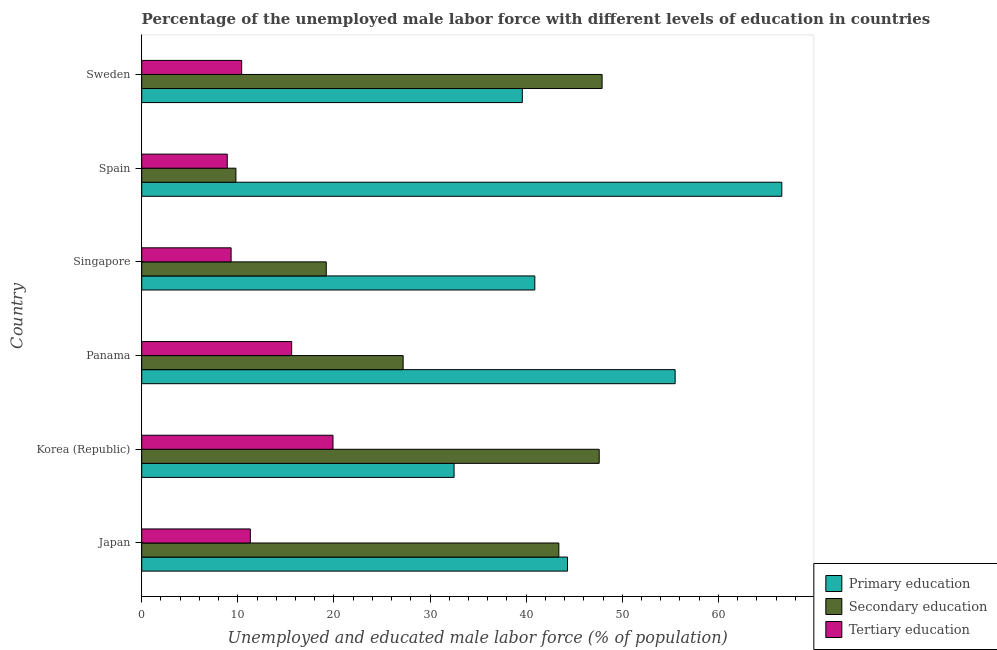How many different coloured bars are there?
Ensure brevity in your answer.  3. How many groups of bars are there?
Give a very brief answer. 6. How many bars are there on the 6th tick from the bottom?
Make the answer very short. 3. In how many cases, is the number of bars for a given country not equal to the number of legend labels?
Provide a succinct answer. 0. What is the percentage of male labor force who received tertiary education in Korea (Republic)?
Give a very brief answer. 19.9. Across all countries, what is the maximum percentage of male labor force who received tertiary education?
Offer a terse response. 19.9. Across all countries, what is the minimum percentage of male labor force who received primary education?
Your answer should be very brief. 32.5. In which country was the percentage of male labor force who received primary education maximum?
Your answer should be very brief. Spain. What is the total percentage of male labor force who received secondary education in the graph?
Keep it short and to the point. 195.1. What is the difference between the percentage of male labor force who received tertiary education in Korea (Republic) and that in Singapore?
Ensure brevity in your answer.  10.6. What is the difference between the percentage of male labor force who received tertiary education in Japan and the percentage of male labor force who received primary education in Singapore?
Offer a very short reply. -29.6. What is the average percentage of male labor force who received tertiary education per country?
Ensure brevity in your answer.  12.57. What is the difference between the percentage of male labor force who received primary education and percentage of male labor force who received tertiary education in Sweden?
Keep it short and to the point. 29.2. In how many countries, is the percentage of male labor force who received tertiary education greater than 16 %?
Your answer should be very brief. 1. What is the ratio of the percentage of male labor force who received tertiary education in Japan to that in Spain?
Offer a terse response. 1.27. Is the percentage of male labor force who received primary education in Panama less than that in Sweden?
Keep it short and to the point. No. What is the difference between the highest and the second highest percentage of male labor force who received primary education?
Make the answer very short. 11.1. What is the difference between the highest and the lowest percentage of male labor force who received secondary education?
Your answer should be very brief. 38.1. In how many countries, is the percentage of male labor force who received primary education greater than the average percentage of male labor force who received primary education taken over all countries?
Offer a very short reply. 2. Is the sum of the percentage of male labor force who received primary education in Singapore and Spain greater than the maximum percentage of male labor force who received tertiary education across all countries?
Give a very brief answer. Yes. What does the 1st bar from the top in Sweden represents?
Make the answer very short. Tertiary education. What does the 3rd bar from the bottom in Spain represents?
Your answer should be compact. Tertiary education. What is the difference between two consecutive major ticks on the X-axis?
Keep it short and to the point. 10. How many legend labels are there?
Your answer should be compact. 3. How are the legend labels stacked?
Your response must be concise. Vertical. What is the title of the graph?
Offer a very short reply. Percentage of the unemployed male labor force with different levels of education in countries. Does "Ages 20-60" appear as one of the legend labels in the graph?
Provide a short and direct response. No. What is the label or title of the X-axis?
Provide a short and direct response. Unemployed and educated male labor force (% of population). What is the label or title of the Y-axis?
Offer a very short reply. Country. What is the Unemployed and educated male labor force (% of population) in Primary education in Japan?
Your response must be concise. 44.3. What is the Unemployed and educated male labor force (% of population) in Secondary education in Japan?
Your answer should be very brief. 43.4. What is the Unemployed and educated male labor force (% of population) in Tertiary education in Japan?
Provide a succinct answer. 11.3. What is the Unemployed and educated male labor force (% of population) in Primary education in Korea (Republic)?
Offer a very short reply. 32.5. What is the Unemployed and educated male labor force (% of population) of Secondary education in Korea (Republic)?
Provide a succinct answer. 47.6. What is the Unemployed and educated male labor force (% of population) in Tertiary education in Korea (Republic)?
Make the answer very short. 19.9. What is the Unemployed and educated male labor force (% of population) of Primary education in Panama?
Keep it short and to the point. 55.5. What is the Unemployed and educated male labor force (% of population) in Secondary education in Panama?
Give a very brief answer. 27.2. What is the Unemployed and educated male labor force (% of population) in Tertiary education in Panama?
Your answer should be compact. 15.6. What is the Unemployed and educated male labor force (% of population) in Primary education in Singapore?
Provide a short and direct response. 40.9. What is the Unemployed and educated male labor force (% of population) in Secondary education in Singapore?
Your response must be concise. 19.2. What is the Unemployed and educated male labor force (% of population) of Tertiary education in Singapore?
Your response must be concise. 9.3. What is the Unemployed and educated male labor force (% of population) in Primary education in Spain?
Keep it short and to the point. 66.6. What is the Unemployed and educated male labor force (% of population) in Secondary education in Spain?
Provide a short and direct response. 9.8. What is the Unemployed and educated male labor force (% of population) of Tertiary education in Spain?
Keep it short and to the point. 8.9. What is the Unemployed and educated male labor force (% of population) in Primary education in Sweden?
Ensure brevity in your answer.  39.6. What is the Unemployed and educated male labor force (% of population) in Secondary education in Sweden?
Your answer should be compact. 47.9. What is the Unemployed and educated male labor force (% of population) in Tertiary education in Sweden?
Make the answer very short. 10.4. Across all countries, what is the maximum Unemployed and educated male labor force (% of population) of Primary education?
Your answer should be compact. 66.6. Across all countries, what is the maximum Unemployed and educated male labor force (% of population) in Secondary education?
Ensure brevity in your answer.  47.9. Across all countries, what is the maximum Unemployed and educated male labor force (% of population) in Tertiary education?
Your answer should be compact. 19.9. Across all countries, what is the minimum Unemployed and educated male labor force (% of population) in Primary education?
Offer a terse response. 32.5. Across all countries, what is the minimum Unemployed and educated male labor force (% of population) of Secondary education?
Offer a terse response. 9.8. Across all countries, what is the minimum Unemployed and educated male labor force (% of population) in Tertiary education?
Ensure brevity in your answer.  8.9. What is the total Unemployed and educated male labor force (% of population) of Primary education in the graph?
Keep it short and to the point. 279.4. What is the total Unemployed and educated male labor force (% of population) of Secondary education in the graph?
Provide a succinct answer. 195.1. What is the total Unemployed and educated male labor force (% of population) of Tertiary education in the graph?
Give a very brief answer. 75.4. What is the difference between the Unemployed and educated male labor force (% of population) in Secondary education in Japan and that in Korea (Republic)?
Give a very brief answer. -4.2. What is the difference between the Unemployed and educated male labor force (% of population) in Primary education in Japan and that in Panama?
Your answer should be compact. -11.2. What is the difference between the Unemployed and educated male labor force (% of population) of Secondary education in Japan and that in Panama?
Your answer should be compact. 16.2. What is the difference between the Unemployed and educated male labor force (% of population) in Tertiary education in Japan and that in Panama?
Ensure brevity in your answer.  -4.3. What is the difference between the Unemployed and educated male labor force (% of population) in Primary education in Japan and that in Singapore?
Offer a terse response. 3.4. What is the difference between the Unemployed and educated male labor force (% of population) in Secondary education in Japan and that in Singapore?
Give a very brief answer. 24.2. What is the difference between the Unemployed and educated male labor force (% of population) of Primary education in Japan and that in Spain?
Provide a short and direct response. -22.3. What is the difference between the Unemployed and educated male labor force (% of population) of Secondary education in Japan and that in Spain?
Keep it short and to the point. 33.6. What is the difference between the Unemployed and educated male labor force (% of population) of Tertiary education in Japan and that in Spain?
Ensure brevity in your answer.  2.4. What is the difference between the Unemployed and educated male labor force (% of population) of Secondary education in Japan and that in Sweden?
Offer a very short reply. -4.5. What is the difference between the Unemployed and educated male labor force (% of population) in Tertiary education in Japan and that in Sweden?
Offer a very short reply. 0.9. What is the difference between the Unemployed and educated male labor force (% of population) in Secondary education in Korea (Republic) and that in Panama?
Provide a short and direct response. 20.4. What is the difference between the Unemployed and educated male labor force (% of population) of Tertiary education in Korea (Republic) and that in Panama?
Your answer should be compact. 4.3. What is the difference between the Unemployed and educated male labor force (% of population) of Primary education in Korea (Republic) and that in Singapore?
Offer a terse response. -8.4. What is the difference between the Unemployed and educated male labor force (% of population) of Secondary education in Korea (Republic) and that in Singapore?
Offer a very short reply. 28.4. What is the difference between the Unemployed and educated male labor force (% of population) in Tertiary education in Korea (Republic) and that in Singapore?
Offer a terse response. 10.6. What is the difference between the Unemployed and educated male labor force (% of population) of Primary education in Korea (Republic) and that in Spain?
Offer a terse response. -34.1. What is the difference between the Unemployed and educated male labor force (% of population) of Secondary education in Korea (Republic) and that in Spain?
Give a very brief answer. 37.8. What is the difference between the Unemployed and educated male labor force (% of population) in Primary education in Korea (Republic) and that in Sweden?
Ensure brevity in your answer.  -7.1. What is the difference between the Unemployed and educated male labor force (% of population) in Secondary education in Korea (Republic) and that in Sweden?
Ensure brevity in your answer.  -0.3. What is the difference between the Unemployed and educated male labor force (% of population) of Tertiary education in Panama and that in Singapore?
Provide a short and direct response. 6.3. What is the difference between the Unemployed and educated male labor force (% of population) in Tertiary education in Panama and that in Spain?
Ensure brevity in your answer.  6.7. What is the difference between the Unemployed and educated male labor force (% of population) of Secondary education in Panama and that in Sweden?
Provide a succinct answer. -20.7. What is the difference between the Unemployed and educated male labor force (% of population) in Primary education in Singapore and that in Spain?
Give a very brief answer. -25.7. What is the difference between the Unemployed and educated male labor force (% of population) in Secondary education in Singapore and that in Spain?
Offer a terse response. 9.4. What is the difference between the Unemployed and educated male labor force (% of population) in Primary education in Singapore and that in Sweden?
Ensure brevity in your answer.  1.3. What is the difference between the Unemployed and educated male labor force (% of population) in Secondary education in Singapore and that in Sweden?
Give a very brief answer. -28.7. What is the difference between the Unemployed and educated male labor force (% of population) of Primary education in Spain and that in Sweden?
Your answer should be compact. 27. What is the difference between the Unemployed and educated male labor force (% of population) of Secondary education in Spain and that in Sweden?
Keep it short and to the point. -38.1. What is the difference between the Unemployed and educated male labor force (% of population) in Primary education in Japan and the Unemployed and educated male labor force (% of population) in Tertiary education in Korea (Republic)?
Ensure brevity in your answer.  24.4. What is the difference between the Unemployed and educated male labor force (% of population) in Secondary education in Japan and the Unemployed and educated male labor force (% of population) in Tertiary education in Korea (Republic)?
Your answer should be compact. 23.5. What is the difference between the Unemployed and educated male labor force (% of population) of Primary education in Japan and the Unemployed and educated male labor force (% of population) of Secondary education in Panama?
Provide a succinct answer. 17.1. What is the difference between the Unemployed and educated male labor force (% of population) in Primary education in Japan and the Unemployed and educated male labor force (% of population) in Tertiary education in Panama?
Keep it short and to the point. 28.7. What is the difference between the Unemployed and educated male labor force (% of population) in Secondary education in Japan and the Unemployed and educated male labor force (% of population) in Tertiary education in Panama?
Offer a very short reply. 27.8. What is the difference between the Unemployed and educated male labor force (% of population) in Primary education in Japan and the Unemployed and educated male labor force (% of population) in Secondary education in Singapore?
Keep it short and to the point. 25.1. What is the difference between the Unemployed and educated male labor force (% of population) of Secondary education in Japan and the Unemployed and educated male labor force (% of population) of Tertiary education in Singapore?
Provide a short and direct response. 34.1. What is the difference between the Unemployed and educated male labor force (% of population) in Primary education in Japan and the Unemployed and educated male labor force (% of population) in Secondary education in Spain?
Ensure brevity in your answer.  34.5. What is the difference between the Unemployed and educated male labor force (% of population) in Primary education in Japan and the Unemployed and educated male labor force (% of population) in Tertiary education in Spain?
Keep it short and to the point. 35.4. What is the difference between the Unemployed and educated male labor force (% of population) of Secondary education in Japan and the Unemployed and educated male labor force (% of population) of Tertiary education in Spain?
Your answer should be compact. 34.5. What is the difference between the Unemployed and educated male labor force (% of population) in Primary education in Japan and the Unemployed and educated male labor force (% of population) in Secondary education in Sweden?
Your response must be concise. -3.6. What is the difference between the Unemployed and educated male labor force (% of population) of Primary education in Japan and the Unemployed and educated male labor force (% of population) of Tertiary education in Sweden?
Give a very brief answer. 33.9. What is the difference between the Unemployed and educated male labor force (% of population) in Secondary education in Japan and the Unemployed and educated male labor force (% of population) in Tertiary education in Sweden?
Provide a succinct answer. 33. What is the difference between the Unemployed and educated male labor force (% of population) of Primary education in Korea (Republic) and the Unemployed and educated male labor force (% of population) of Secondary education in Panama?
Provide a succinct answer. 5.3. What is the difference between the Unemployed and educated male labor force (% of population) of Secondary education in Korea (Republic) and the Unemployed and educated male labor force (% of population) of Tertiary education in Panama?
Provide a short and direct response. 32. What is the difference between the Unemployed and educated male labor force (% of population) of Primary education in Korea (Republic) and the Unemployed and educated male labor force (% of population) of Secondary education in Singapore?
Your answer should be compact. 13.3. What is the difference between the Unemployed and educated male labor force (% of population) in Primary education in Korea (Republic) and the Unemployed and educated male labor force (% of population) in Tertiary education in Singapore?
Provide a short and direct response. 23.2. What is the difference between the Unemployed and educated male labor force (% of population) of Secondary education in Korea (Republic) and the Unemployed and educated male labor force (% of population) of Tertiary education in Singapore?
Provide a succinct answer. 38.3. What is the difference between the Unemployed and educated male labor force (% of population) of Primary education in Korea (Republic) and the Unemployed and educated male labor force (% of population) of Secondary education in Spain?
Offer a terse response. 22.7. What is the difference between the Unemployed and educated male labor force (% of population) of Primary education in Korea (Republic) and the Unemployed and educated male labor force (% of population) of Tertiary education in Spain?
Your answer should be compact. 23.6. What is the difference between the Unemployed and educated male labor force (% of population) in Secondary education in Korea (Republic) and the Unemployed and educated male labor force (% of population) in Tertiary education in Spain?
Give a very brief answer. 38.7. What is the difference between the Unemployed and educated male labor force (% of population) of Primary education in Korea (Republic) and the Unemployed and educated male labor force (% of population) of Secondary education in Sweden?
Ensure brevity in your answer.  -15.4. What is the difference between the Unemployed and educated male labor force (% of population) of Primary education in Korea (Republic) and the Unemployed and educated male labor force (% of population) of Tertiary education in Sweden?
Make the answer very short. 22.1. What is the difference between the Unemployed and educated male labor force (% of population) of Secondary education in Korea (Republic) and the Unemployed and educated male labor force (% of population) of Tertiary education in Sweden?
Provide a succinct answer. 37.2. What is the difference between the Unemployed and educated male labor force (% of population) in Primary education in Panama and the Unemployed and educated male labor force (% of population) in Secondary education in Singapore?
Offer a very short reply. 36.3. What is the difference between the Unemployed and educated male labor force (% of population) in Primary education in Panama and the Unemployed and educated male labor force (% of population) in Tertiary education in Singapore?
Keep it short and to the point. 46.2. What is the difference between the Unemployed and educated male labor force (% of population) in Secondary education in Panama and the Unemployed and educated male labor force (% of population) in Tertiary education in Singapore?
Your response must be concise. 17.9. What is the difference between the Unemployed and educated male labor force (% of population) in Primary education in Panama and the Unemployed and educated male labor force (% of population) in Secondary education in Spain?
Keep it short and to the point. 45.7. What is the difference between the Unemployed and educated male labor force (% of population) in Primary education in Panama and the Unemployed and educated male labor force (% of population) in Tertiary education in Spain?
Ensure brevity in your answer.  46.6. What is the difference between the Unemployed and educated male labor force (% of population) in Secondary education in Panama and the Unemployed and educated male labor force (% of population) in Tertiary education in Spain?
Ensure brevity in your answer.  18.3. What is the difference between the Unemployed and educated male labor force (% of population) of Primary education in Panama and the Unemployed and educated male labor force (% of population) of Secondary education in Sweden?
Your answer should be compact. 7.6. What is the difference between the Unemployed and educated male labor force (% of population) in Primary education in Panama and the Unemployed and educated male labor force (% of population) in Tertiary education in Sweden?
Offer a terse response. 45.1. What is the difference between the Unemployed and educated male labor force (% of population) of Secondary education in Panama and the Unemployed and educated male labor force (% of population) of Tertiary education in Sweden?
Offer a very short reply. 16.8. What is the difference between the Unemployed and educated male labor force (% of population) of Primary education in Singapore and the Unemployed and educated male labor force (% of population) of Secondary education in Spain?
Give a very brief answer. 31.1. What is the difference between the Unemployed and educated male labor force (% of population) of Secondary education in Singapore and the Unemployed and educated male labor force (% of population) of Tertiary education in Spain?
Your response must be concise. 10.3. What is the difference between the Unemployed and educated male labor force (% of population) of Primary education in Singapore and the Unemployed and educated male labor force (% of population) of Secondary education in Sweden?
Offer a terse response. -7. What is the difference between the Unemployed and educated male labor force (% of population) of Primary education in Singapore and the Unemployed and educated male labor force (% of population) of Tertiary education in Sweden?
Give a very brief answer. 30.5. What is the difference between the Unemployed and educated male labor force (% of population) in Secondary education in Singapore and the Unemployed and educated male labor force (% of population) in Tertiary education in Sweden?
Your response must be concise. 8.8. What is the difference between the Unemployed and educated male labor force (% of population) in Primary education in Spain and the Unemployed and educated male labor force (% of population) in Secondary education in Sweden?
Ensure brevity in your answer.  18.7. What is the difference between the Unemployed and educated male labor force (% of population) of Primary education in Spain and the Unemployed and educated male labor force (% of population) of Tertiary education in Sweden?
Your response must be concise. 56.2. What is the average Unemployed and educated male labor force (% of population) in Primary education per country?
Offer a very short reply. 46.57. What is the average Unemployed and educated male labor force (% of population) of Secondary education per country?
Offer a terse response. 32.52. What is the average Unemployed and educated male labor force (% of population) of Tertiary education per country?
Your answer should be compact. 12.57. What is the difference between the Unemployed and educated male labor force (% of population) in Secondary education and Unemployed and educated male labor force (% of population) in Tertiary education in Japan?
Provide a succinct answer. 32.1. What is the difference between the Unemployed and educated male labor force (% of population) in Primary education and Unemployed and educated male labor force (% of population) in Secondary education in Korea (Republic)?
Make the answer very short. -15.1. What is the difference between the Unemployed and educated male labor force (% of population) of Secondary education and Unemployed and educated male labor force (% of population) of Tertiary education in Korea (Republic)?
Offer a very short reply. 27.7. What is the difference between the Unemployed and educated male labor force (% of population) in Primary education and Unemployed and educated male labor force (% of population) in Secondary education in Panama?
Ensure brevity in your answer.  28.3. What is the difference between the Unemployed and educated male labor force (% of population) in Primary education and Unemployed and educated male labor force (% of population) in Tertiary education in Panama?
Provide a succinct answer. 39.9. What is the difference between the Unemployed and educated male labor force (% of population) of Primary education and Unemployed and educated male labor force (% of population) of Secondary education in Singapore?
Give a very brief answer. 21.7. What is the difference between the Unemployed and educated male labor force (% of population) in Primary education and Unemployed and educated male labor force (% of population) in Tertiary education in Singapore?
Ensure brevity in your answer.  31.6. What is the difference between the Unemployed and educated male labor force (% of population) of Primary education and Unemployed and educated male labor force (% of population) of Secondary education in Spain?
Give a very brief answer. 56.8. What is the difference between the Unemployed and educated male labor force (% of population) of Primary education and Unemployed and educated male labor force (% of population) of Tertiary education in Spain?
Your response must be concise. 57.7. What is the difference between the Unemployed and educated male labor force (% of population) in Secondary education and Unemployed and educated male labor force (% of population) in Tertiary education in Spain?
Ensure brevity in your answer.  0.9. What is the difference between the Unemployed and educated male labor force (% of population) of Primary education and Unemployed and educated male labor force (% of population) of Secondary education in Sweden?
Keep it short and to the point. -8.3. What is the difference between the Unemployed and educated male labor force (% of population) in Primary education and Unemployed and educated male labor force (% of population) in Tertiary education in Sweden?
Offer a very short reply. 29.2. What is the difference between the Unemployed and educated male labor force (% of population) in Secondary education and Unemployed and educated male labor force (% of population) in Tertiary education in Sweden?
Give a very brief answer. 37.5. What is the ratio of the Unemployed and educated male labor force (% of population) in Primary education in Japan to that in Korea (Republic)?
Provide a succinct answer. 1.36. What is the ratio of the Unemployed and educated male labor force (% of population) of Secondary education in Japan to that in Korea (Republic)?
Give a very brief answer. 0.91. What is the ratio of the Unemployed and educated male labor force (% of population) in Tertiary education in Japan to that in Korea (Republic)?
Your response must be concise. 0.57. What is the ratio of the Unemployed and educated male labor force (% of population) of Primary education in Japan to that in Panama?
Keep it short and to the point. 0.8. What is the ratio of the Unemployed and educated male labor force (% of population) of Secondary education in Japan to that in Panama?
Your response must be concise. 1.6. What is the ratio of the Unemployed and educated male labor force (% of population) in Tertiary education in Japan to that in Panama?
Provide a succinct answer. 0.72. What is the ratio of the Unemployed and educated male labor force (% of population) in Primary education in Japan to that in Singapore?
Give a very brief answer. 1.08. What is the ratio of the Unemployed and educated male labor force (% of population) in Secondary education in Japan to that in Singapore?
Provide a short and direct response. 2.26. What is the ratio of the Unemployed and educated male labor force (% of population) in Tertiary education in Japan to that in Singapore?
Your response must be concise. 1.22. What is the ratio of the Unemployed and educated male labor force (% of population) of Primary education in Japan to that in Spain?
Your answer should be very brief. 0.67. What is the ratio of the Unemployed and educated male labor force (% of population) in Secondary education in Japan to that in Spain?
Your answer should be very brief. 4.43. What is the ratio of the Unemployed and educated male labor force (% of population) in Tertiary education in Japan to that in Spain?
Your answer should be compact. 1.27. What is the ratio of the Unemployed and educated male labor force (% of population) of Primary education in Japan to that in Sweden?
Provide a succinct answer. 1.12. What is the ratio of the Unemployed and educated male labor force (% of population) of Secondary education in Japan to that in Sweden?
Provide a short and direct response. 0.91. What is the ratio of the Unemployed and educated male labor force (% of population) in Tertiary education in Japan to that in Sweden?
Your answer should be very brief. 1.09. What is the ratio of the Unemployed and educated male labor force (% of population) in Primary education in Korea (Republic) to that in Panama?
Your response must be concise. 0.59. What is the ratio of the Unemployed and educated male labor force (% of population) in Secondary education in Korea (Republic) to that in Panama?
Your response must be concise. 1.75. What is the ratio of the Unemployed and educated male labor force (% of population) of Tertiary education in Korea (Republic) to that in Panama?
Offer a very short reply. 1.28. What is the ratio of the Unemployed and educated male labor force (% of population) in Primary education in Korea (Republic) to that in Singapore?
Ensure brevity in your answer.  0.79. What is the ratio of the Unemployed and educated male labor force (% of population) of Secondary education in Korea (Republic) to that in Singapore?
Your response must be concise. 2.48. What is the ratio of the Unemployed and educated male labor force (% of population) of Tertiary education in Korea (Republic) to that in Singapore?
Your response must be concise. 2.14. What is the ratio of the Unemployed and educated male labor force (% of population) of Primary education in Korea (Republic) to that in Spain?
Give a very brief answer. 0.49. What is the ratio of the Unemployed and educated male labor force (% of population) of Secondary education in Korea (Republic) to that in Spain?
Make the answer very short. 4.86. What is the ratio of the Unemployed and educated male labor force (% of population) of Tertiary education in Korea (Republic) to that in Spain?
Provide a succinct answer. 2.24. What is the ratio of the Unemployed and educated male labor force (% of population) in Primary education in Korea (Republic) to that in Sweden?
Ensure brevity in your answer.  0.82. What is the ratio of the Unemployed and educated male labor force (% of population) in Tertiary education in Korea (Republic) to that in Sweden?
Keep it short and to the point. 1.91. What is the ratio of the Unemployed and educated male labor force (% of population) of Primary education in Panama to that in Singapore?
Give a very brief answer. 1.36. What is the ratio of the Unemployed and educated male labor force (% of population) in Secondary education in Panama to that in Singapore?
Offer a very short reply. 1.42. What is the ratio of the Unemployed and educated male labor force (% of population) in Tertiary education in Panama to that in Singapore?
Your answer should be very brief. 1.68. What is the ratio of the Unemployed and educated male labor force (% of population) of Primary education in Panama to that in Spain?
Your answer should be compact. 0.83. What is the ratio of the Unemployed and educated male labor force (% of population) of Secondary education in Panama to that in Spain?
Make the answer very short. 2.78. What is the ratio of the Unemployed and educated male labor force (% of population) in Tertiary education in Panama to that in Spain?
Ensure brevity in your answer.  1.75. What is the ratio of the Unemployed and educated male labor force (% of population) in Primary education in Panama to that in Sweden?
Offer a terse response. 1.4. What is the ratio of the Unemployed and educated male labor force (% of population) in Secondary education in Panama to that in Sweden?
Your response must be concise. 0.57. What is the ratio of the Unemployed and educated male labor force (% of population) of Tertiary education in Panama to that in Sweden?
Provide a short and direct response. 1.5. What is the ratio of the Unemployed and educated male labor force (% of population) of Primary education in Singapore to that in Spain?
Your answer should be compact. 0.61. What is the ratio of the Unemployed and educated male labor force (% of population) of Secondary education in Singapore to that in Spain?
Your answer should be very brief. 1.96. What is the ratio of the Unemployed and educated male labor force (% of population) of Tertiary education in Singapore to that in Spain?
Offer a very short reply. 1.04. What is the ratio of the Unemployed and educated male labor force (% of population) in Primary education in Singapore to that in Sweden?
Give a very brief answer. 1.03. What is the ratio of the Unemployed and educated male labor force (% of population) in Secondary education in Singapore to that in Sweden?
Offer a terse response. 0.4. What is the ratio of the Unemployed and educated male labor force (% of population) in Tertiary education in Singapore to that in Sweden?
Provide a succinct answer. 0.89. What is the ratio of the Unemployed and educated male labor force (% of population) in Primary education in Spain to that in Sweden?
Offer a terse response. 1.68. What is the ratio of the Unemployed and educated male labor force (% of population) in Secondary education in Spain to that in Sweden?
Offer a terse response. 0.2. What is the ratio of the Unemployed and educated male labor force (% of population) in Tertiary education in Spain to that in Sweden?
Offer a terse response. 0.86. What is the difference between the highest and the second highest Unemployed and educated male labor force (% of population) of Primary education?
Provide a succinct answer. 11.1. What is the difference between the highest and the second highest Unemployed and educated male labor force (% of population) of Secondary education?
Offer a terse response. 0.3. What is the difference between the highest and the second highest Unemployed and educated male labor force (% of population) of Tertiary education?
Give a very brief answer. 4.3. What is the difference between the highest and the lowest Unemployed and educated male labor force (% of population) of Primary education?
Offer a terse response. 34.1. What is the difference between the highest and the lowest Unemployed and educated male labor force (% of population) in Secondary education?
Provide a succinct answer. 38.1. What is the difference between the highest and the lowest Unemployed and educated male labor force (% of population) of Tertiary education?
Provide a short and direct response. 11. 